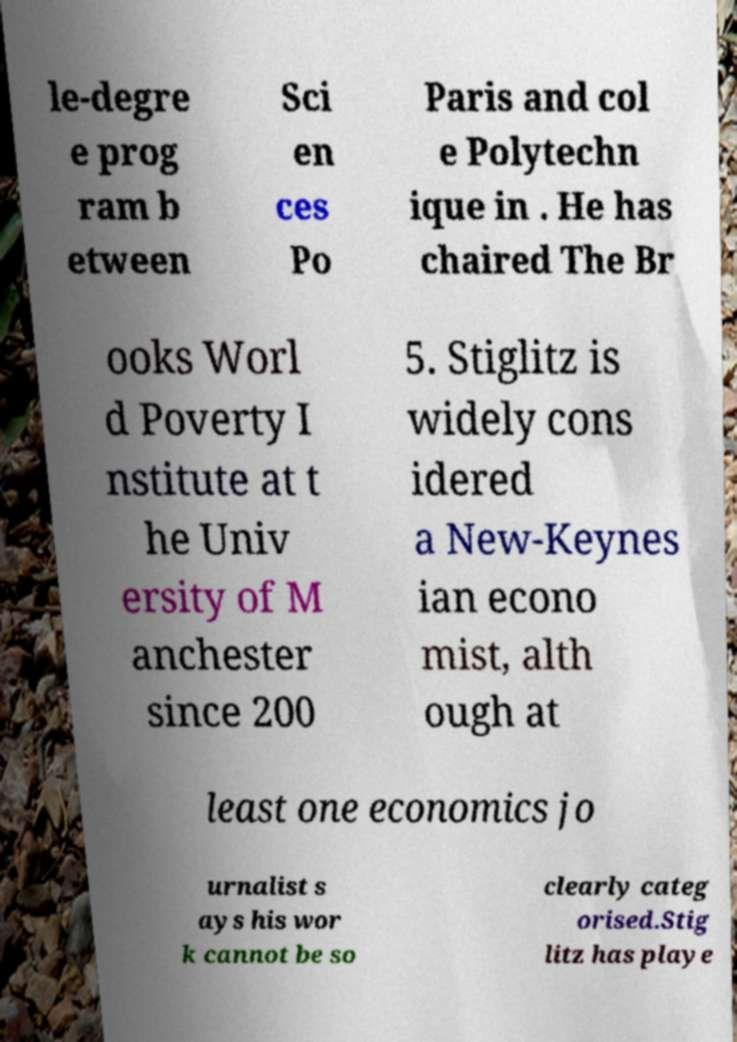For documentation purposes, I need the text within this image transcribed. Could you provide that? le-degre e prog ram b etween Sci en ces Po Paris and col e Polytechn ique in . He has chaired The Br ooks Worl d Poverty I nstitute at t he Univ ersity of M anchester since 200 5. Stiglitz is widely cons idered a New-Keynes ian econo mist, alth ough at least one economics jo urnalist s ays his wor k cannot be so clearly categ orised.Stig litz has playe 